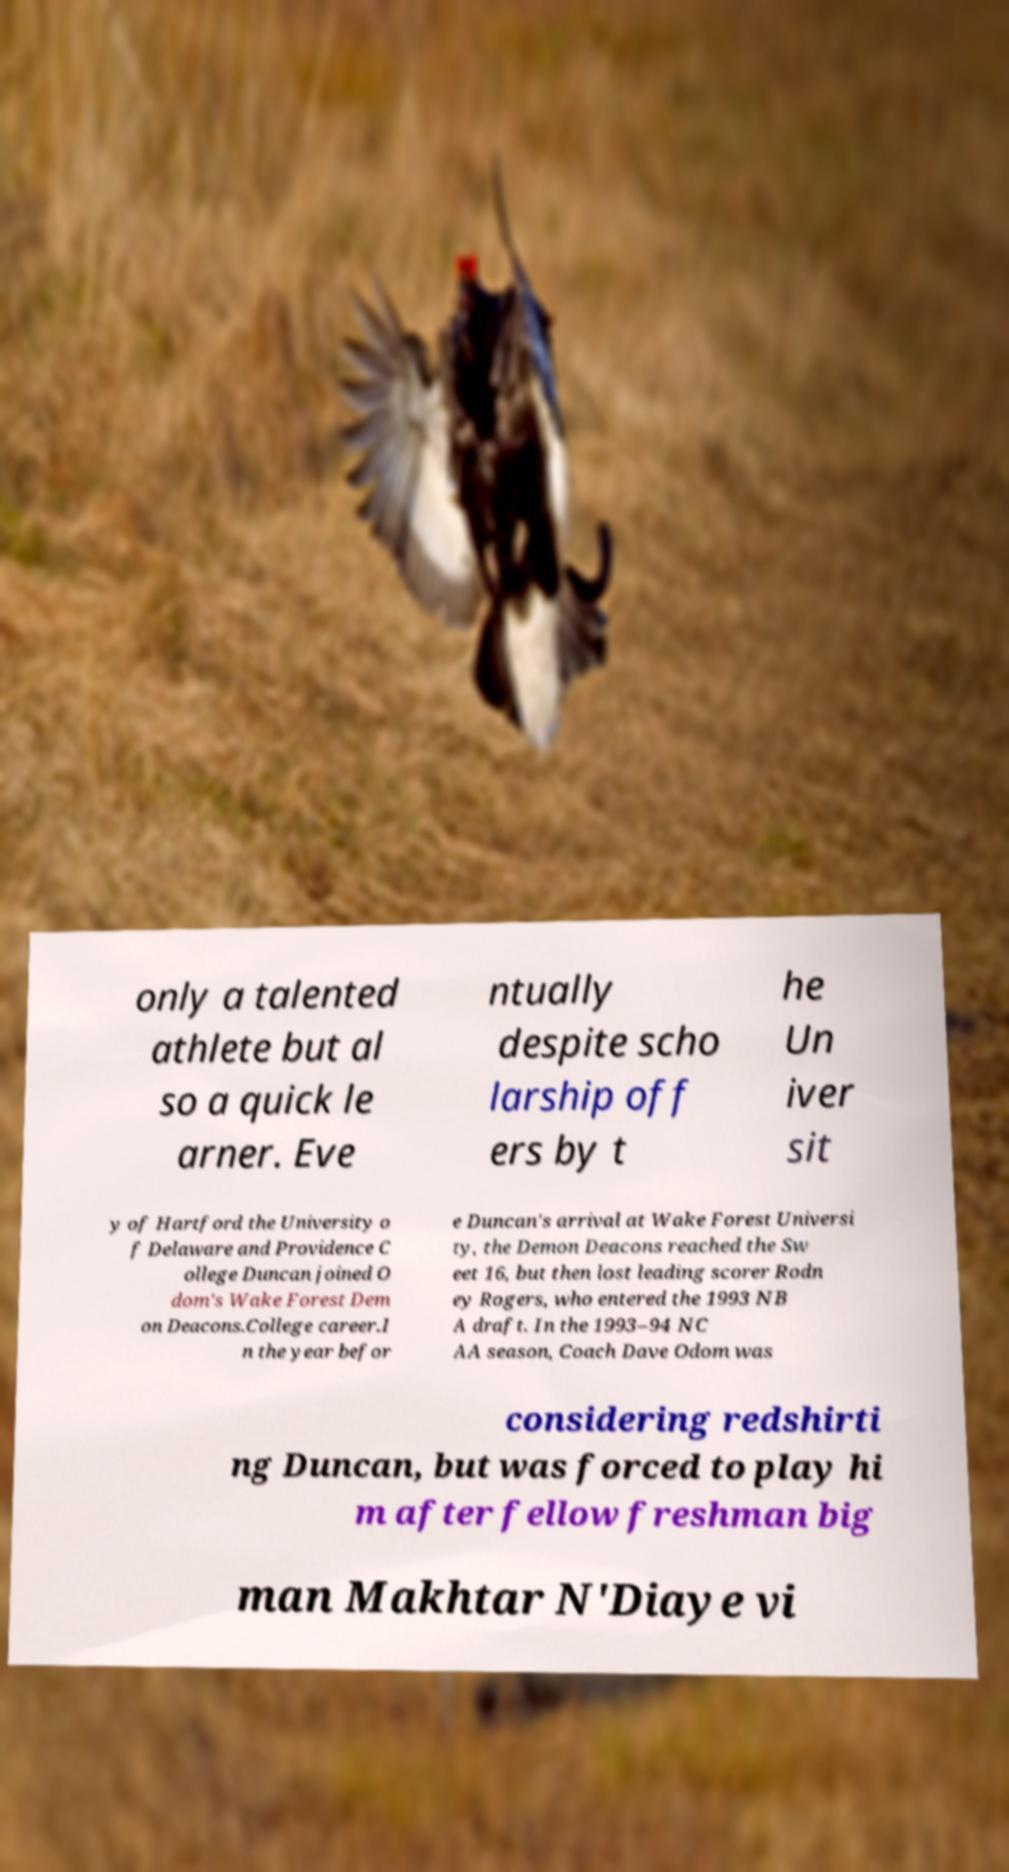Could you extract and type out the text from this image? only a talented athlete but al so a quick le arner. Eve ntually despite scho larship off ers by t he Un iver sit y of Hartford the University o f Delaware and Providence C ollege Duncan joined O dom's Wake Forest Dem on Deacons.College career.I n the year befor e Duncan's arrival at Wake Forest Universi ty, the Demon Deacons reached the Sw eet 16, but then lost leading scorer Rodn ey Rogers, who entered the 1993 NB A draft. In the 1993–94 NC AA season, Coach Dave Odom was considering redshirti ng Duncan, but was forced to play hi m after fellow freshman big man Makhtar N'Diaye vi 